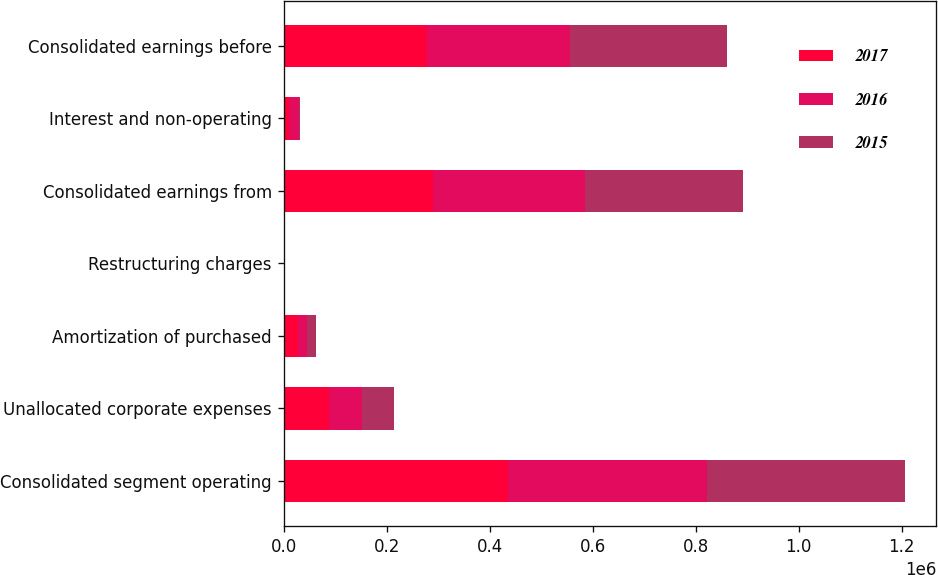Convert chart. <chart><loc_0><loc_0><loc_500><loc_500><stacked_bar_chart><ecel><fcel>Consolidated segment operating<fcel>Unallocated corporate expenses<fcel>Amortization of purchased<fcel>Restructuring charges<fcel>Consolidated earnings from<fcel>Interest and non-operating<fcel>Consolidated earnings before<nl><fcel>2017<fcel>435129<fcel>87184<fcel>27391<fcel>625<fcel>289961<fcel>10896<fcel>279065<nl><fcel>2016<fcel>386157<fcel>65012<fcel>18266<fcel>1431<fcel>295718<fcel>19761<fcel>275957<nl><fcel>2015<fcel>385346<fcel>61946<fcel>16275<fcel>1361<fcel>305764<fcel>318<fcel>305446<nl></chart> 